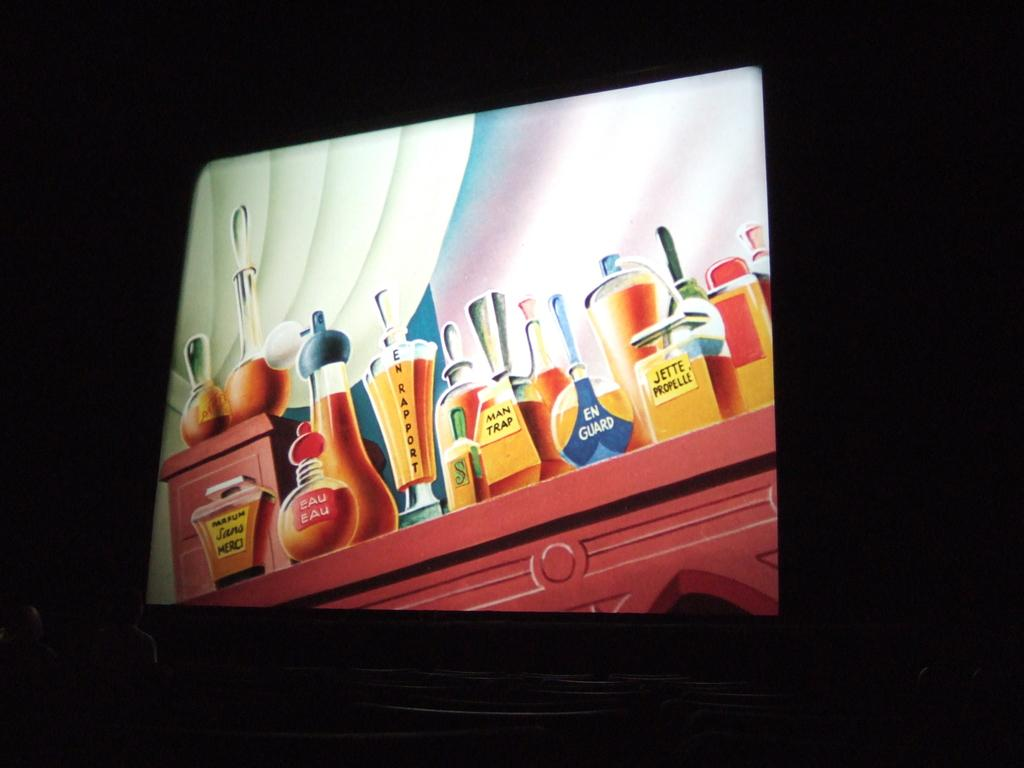Provide a one-sentence caption for the provided image. A screen grab of a coolourful cartoon of perfume bottles called en guard and eau eau amongst others. 